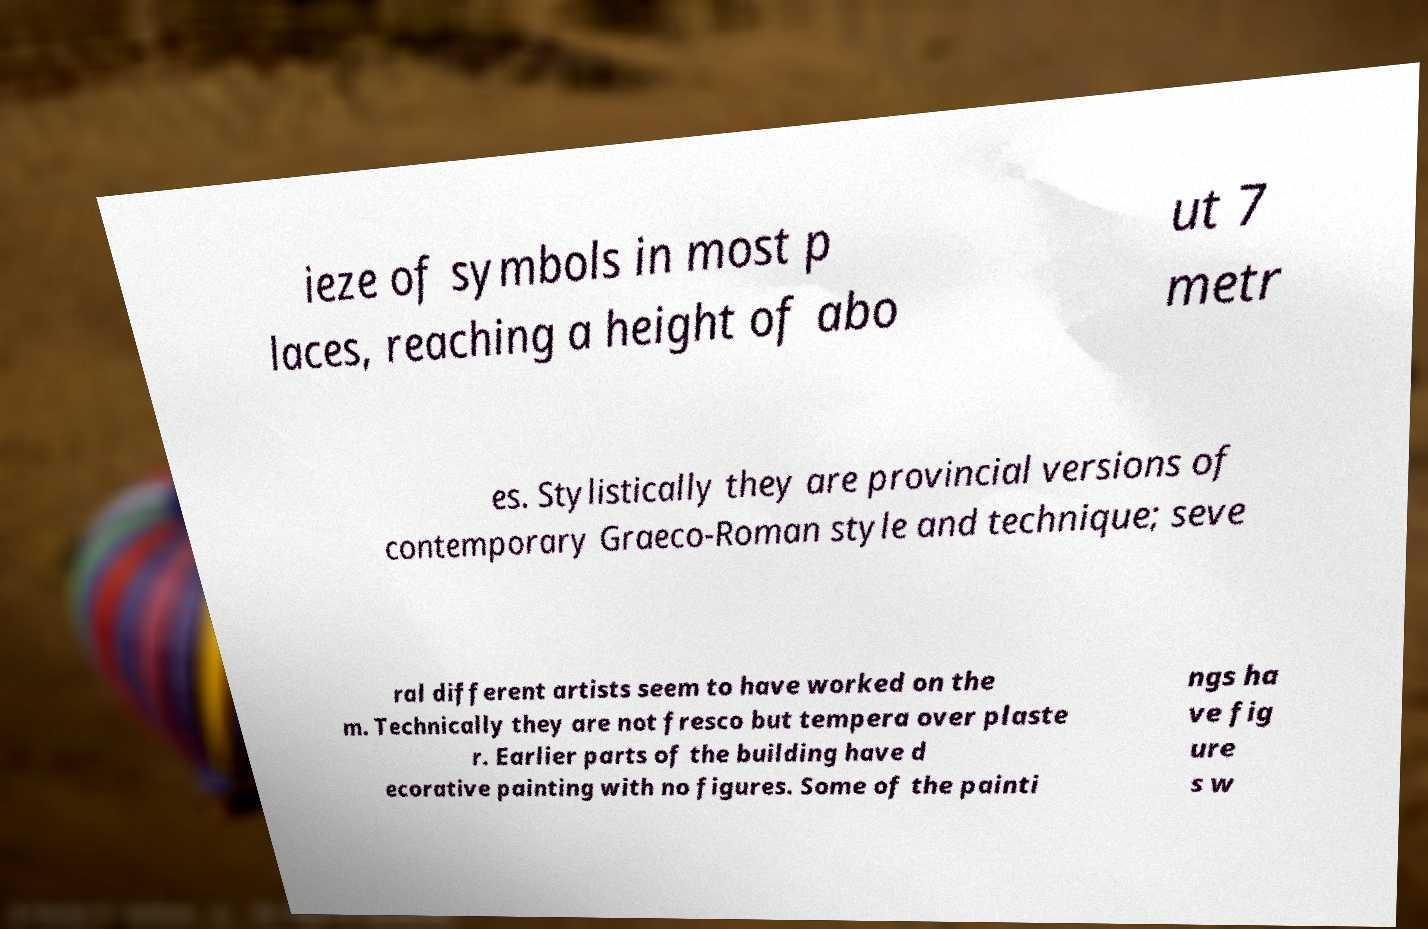Could you assist in decoding the text presented in this image and type it out clearly? ieze of symbols in most p laces, reaching a height of abo ut 7 metr es. Stylistically they are provincial versions of contemporary Graeco-Roman style and technique; seve ral different artists seem to have worked on the m. Technically they are not fresco but tempera over plaste r. Earlier parts of the building have d ecorative painting with no figures. Some of the painti ngs ha ve fig ure s w 